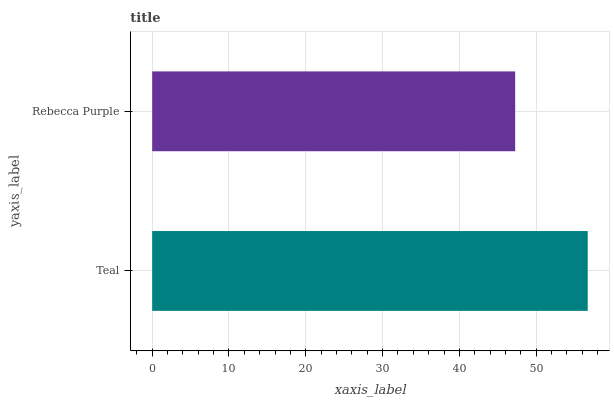Is Rebecca Purple the minimum?
Answer yes or no. Yes. Is Teal the maximum?
Answer yes or no. Yes. Is Rebecca Purple the maximum?
Answer yes or no. No. Is Teal greater than Rebecca Purple?
Answer yes or no. Yes. Is Rebecca Purple less than Teal?
Answer yes or no. Yes. Is Rebecca Purple greater than Teal?
Answer yes or no. No. Is Teal less than Rebecca Purple?
Answer yes or no. No. Is Teal the high median?
Answer yes or no. Yes. Is Rebecca Purple the low median?
Answer yes or no. Yes. Is Rebecca Purple the high median?
Answer yes or no. No. Is Teal the low median?
Answer yes or no. No. 